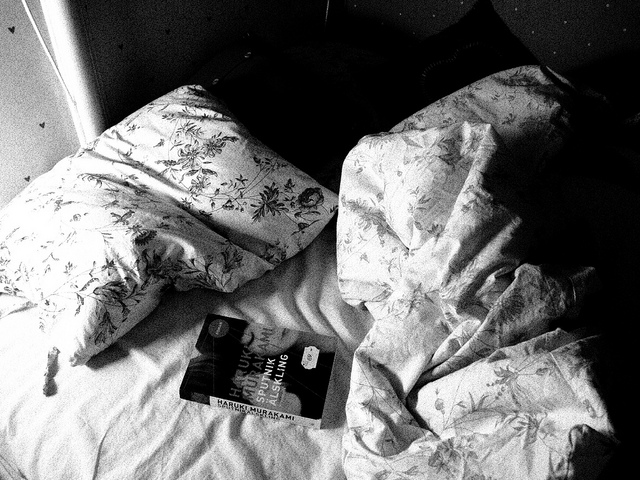Identify the text contained in this image. SPUTNIK ALSKLING SPUTNIK THURAKAMI HARUKI 